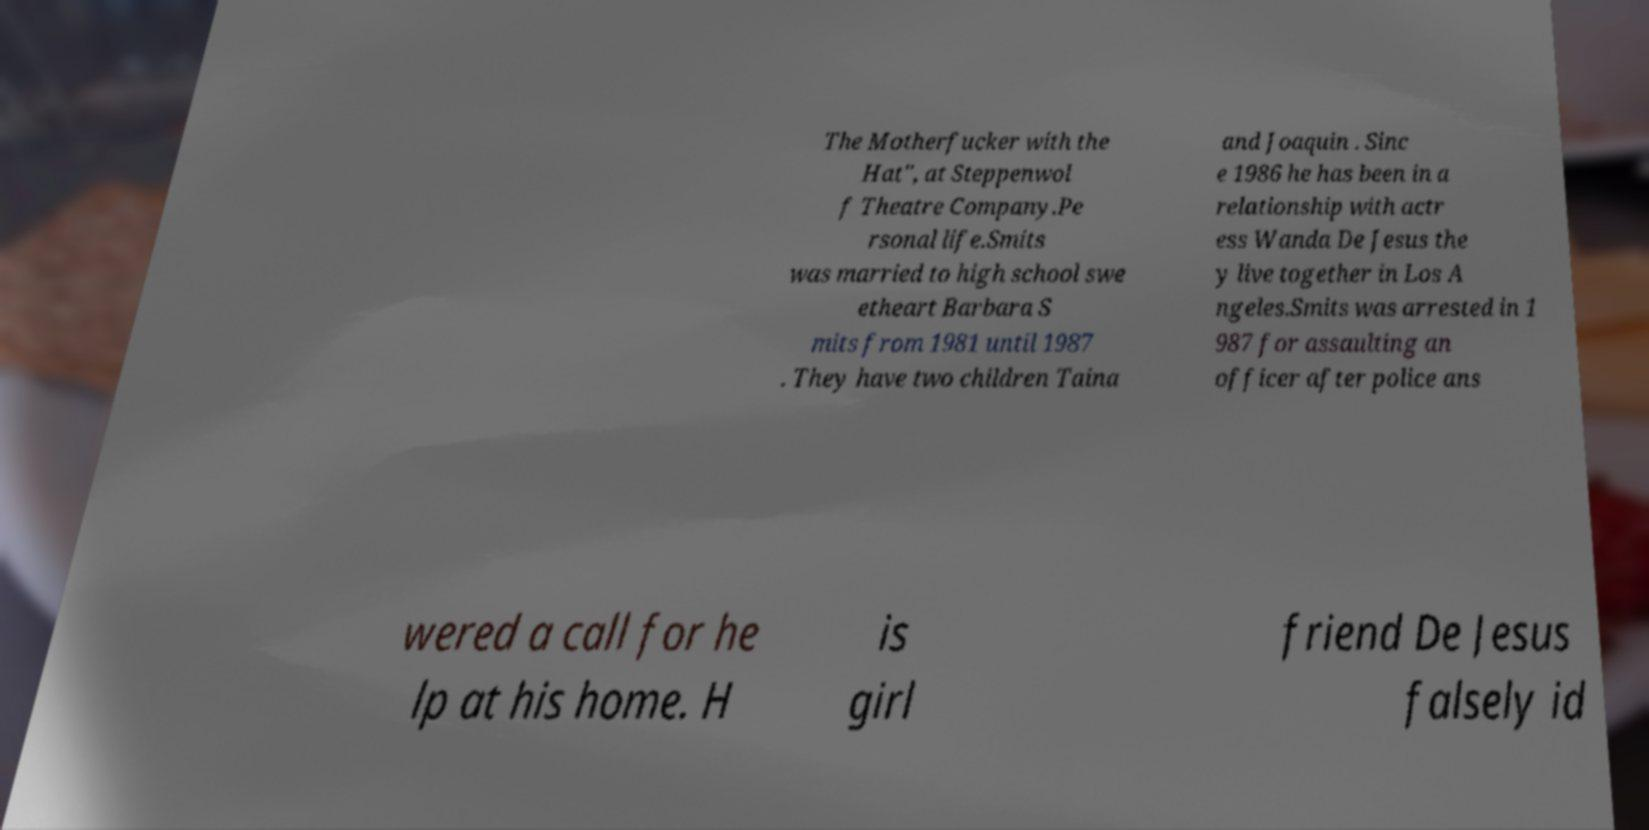Can you accurately transcribe the text from the provided image for me? The Motherfucker with the Hat", at Steppenwol f Theatre Company.Pe rsonal life.Smits was married to high school swe etheart Barbara S mits from 1981 until 1987 . They have two children Taina and Joaquin . Sinc e 1986 he has been in a relationship with actr ess Wanda De Jesus the y live together in Los A ngeles.Smits was arrested in 1 987 for assaulting an officer after police ans wered a call for he lp at his home. H is girl friend De Jesus falsely id 